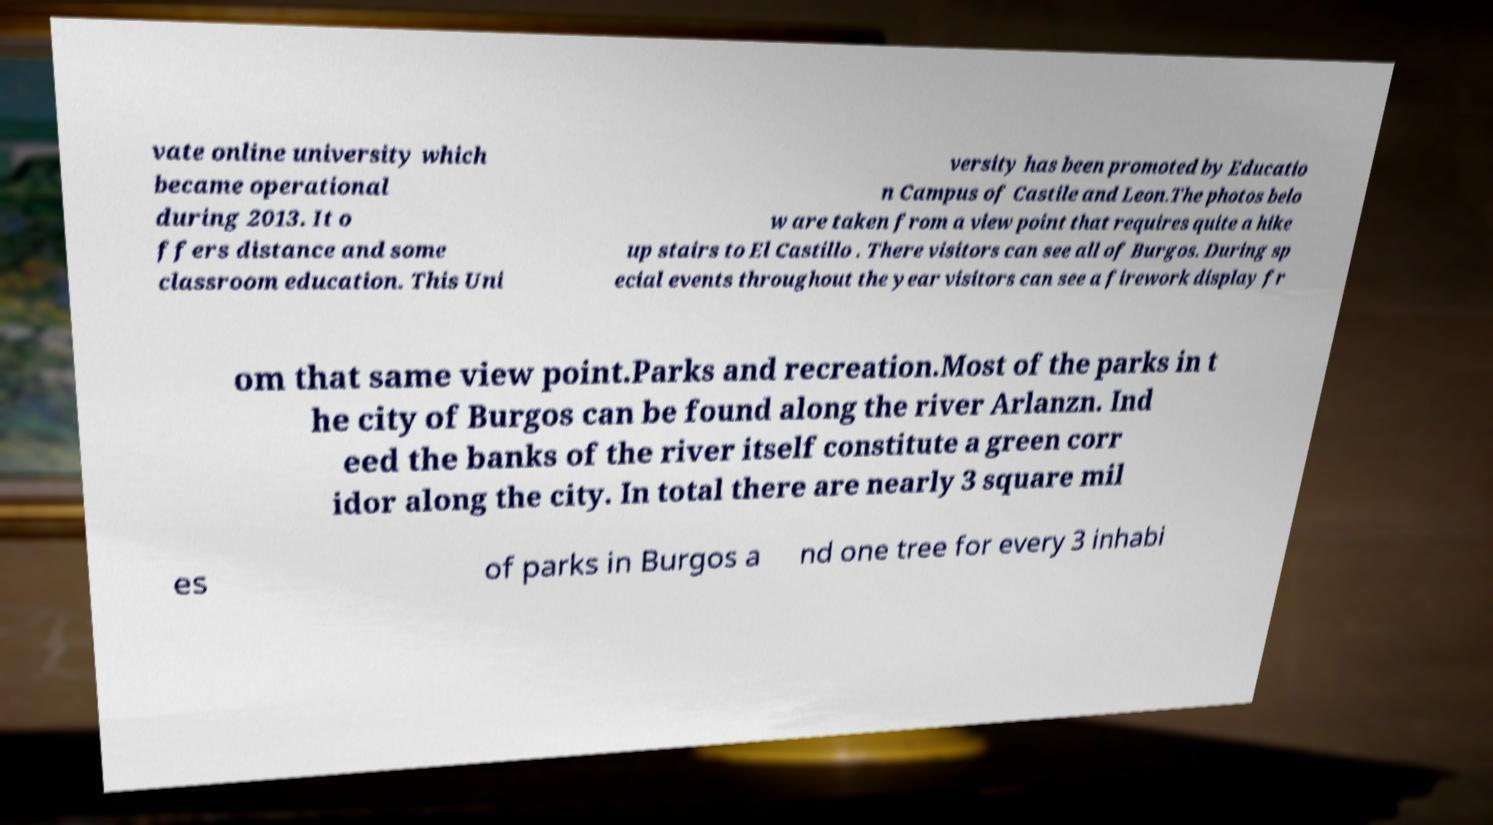For documentation purposes, I need the text within this image transcribed. Could you provide that? vate online university which became operational during 2013. It o ffers distance and some classroom education. This Uni versity has been promoted by Educatio n Campus of Castile and Leon.The photos belo w are taken from a view point that requires quite a hike up stairs to El Castillo . There visitors can see all of Burgos. During sp ecial events throughout the year visitors can see a firework display fr om that same view point.Parks and recreation.Most of the parks in t he city of Burgos can be found along the river Arlanzn. Ind eed the banks of the river itself constitute a green corr idor along the city. In total there are nearly 3 square mil es of parks in Burgos a nd one tree for every 3 inhabi 